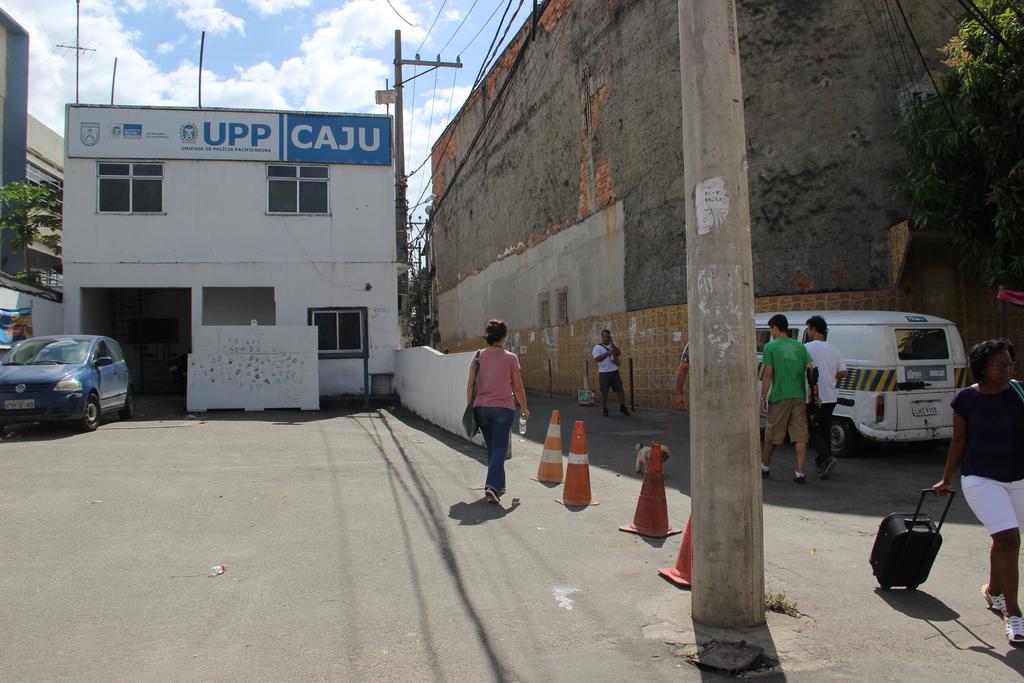What is written on the blue sign?
Offer a terse response. Caju. What is written on the white sign?
Your answer should be compact. Upp. 